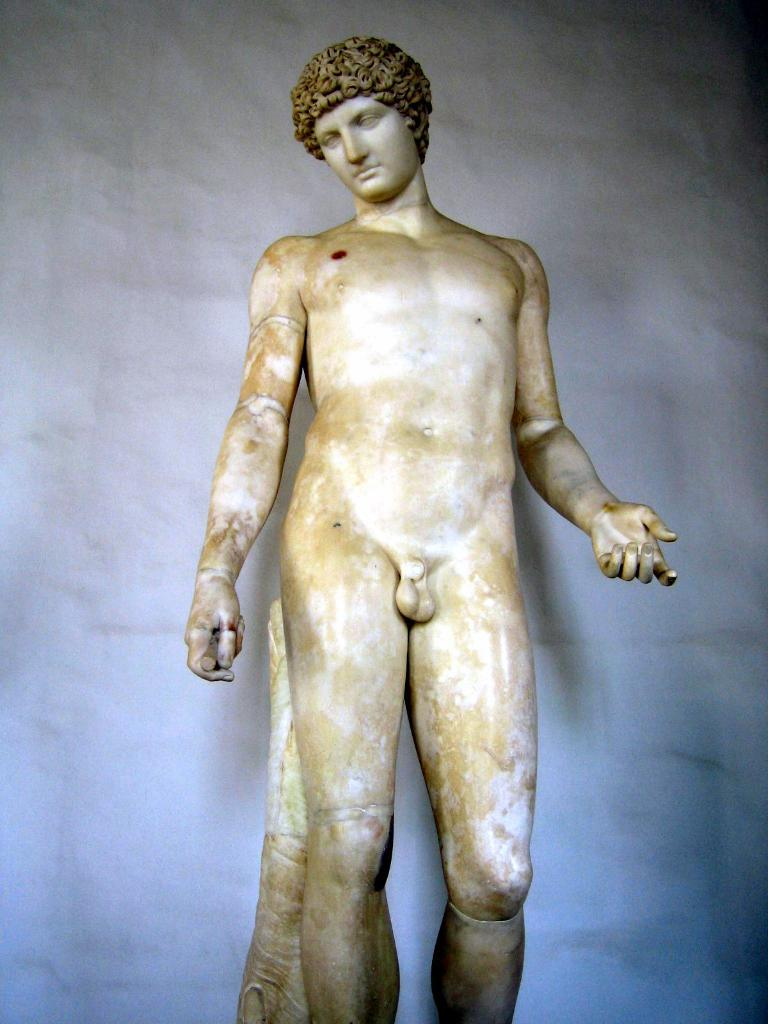What is the main subject of the image? There is a sculpture of a man in the image. Can you describe the appearance of the sculpture? The sculpture is white and brown in color. What can be seen in the background of the image? There is a white wall in the background of the image. Is the man wearing a veil in the sculpture? There is no veil present in the sculpture; it is a sculpture of a man without any clothing or accessories. 